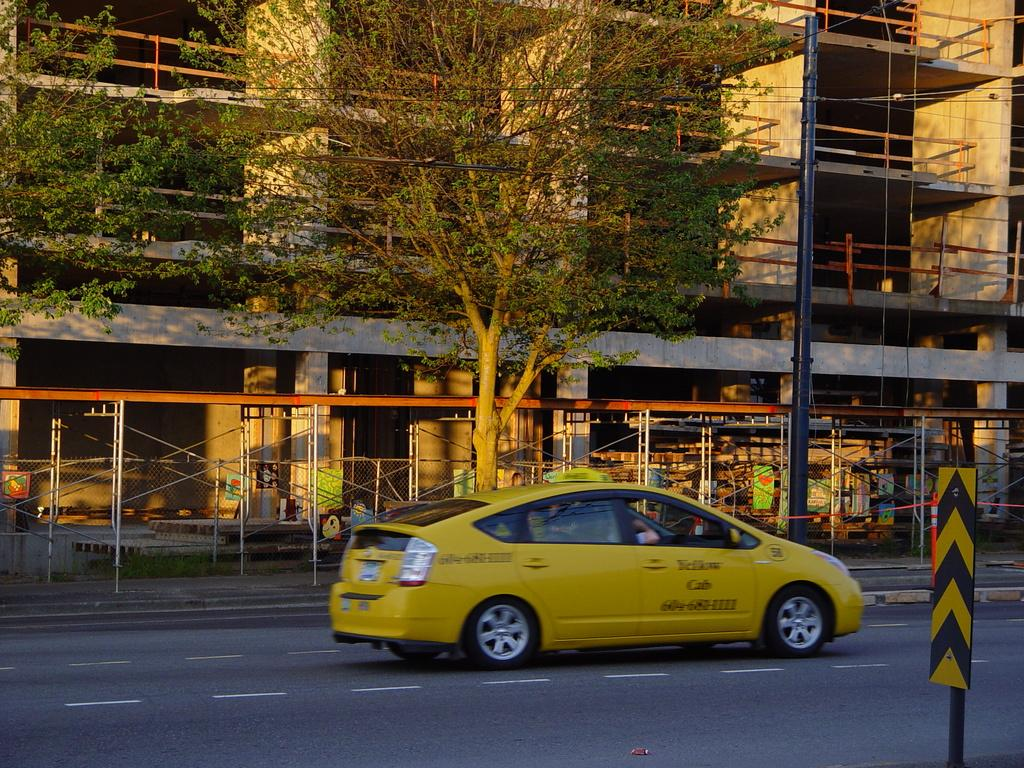<image>
Render a clear and concise summary of the photo. a yellow cab with a phone number on the side 